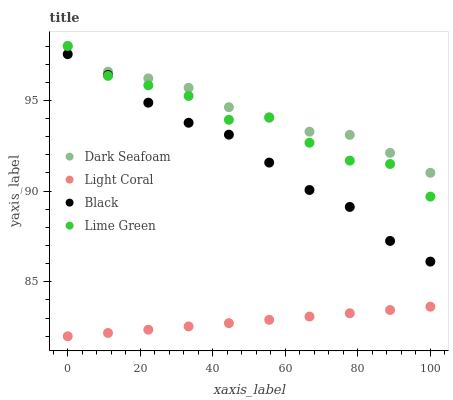Does Light Coral have the minimum area under the curve?
Answer yes or no. Yes. Does Dark Seafoam have the maximum area under the curve?
Answer yes or no. Yes. Does Lime Green have the minimum area under the curve?
Answer yes or no. No. Does Lime Green have the maximum area under the curve?
Answer yes or no. No. Is Light Coral the smoothest?
Answer yes or no. Yes. Is Lime Green the roughest?
Answer yes or no. Yes. Is Dark Seafoam the smoothest?
Answer yes or no. No. Is Dark Seafoam the roughest?
Answer yes or no. No. Does Light Coral have the lowest value?
Answer yes or no. Yes. Does Lime Green have the lowest value?
Answer yes or no. No. Does Dark Seafoam have the highest value?
Answer yes or no. Yes. Does Black have the highest value?
Answer yes or no. No. Is Light Coral less than Black?
Answer yes or no. Yes. Is Dark Seafoam greater than Black?
Answer yes or no. Yes. Does Lime Green intersect Black?
Answer yes or no. Yes. Is Lime Green less than Black?
Answer yes or no. No. Is Lime Green greater than Black?
Answer yes or no. No. Does Light Coral intersect Black?
Answer yes or no. No. 